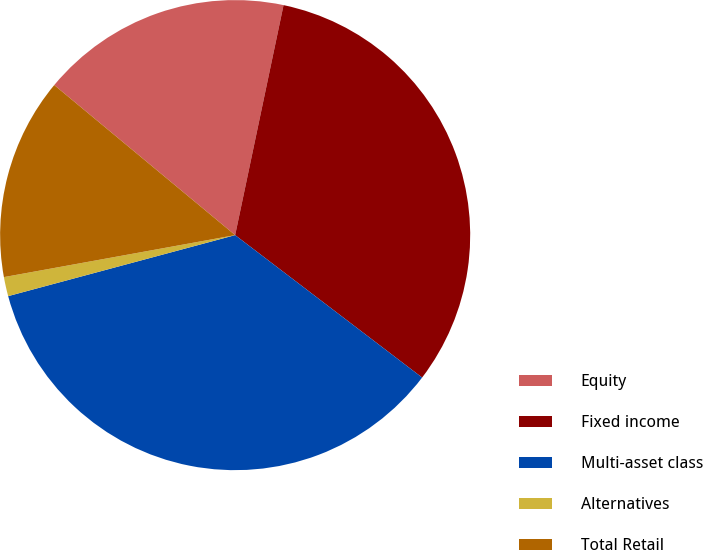<chart> <loc_0><loc_0><loc_500><loc_500><pie_chart><fcel>Equity<fcel>Fixed income<fcel>Multi-asset class<fcel>Alternatives<fcel>Total Retail<nl><fcel>17.28%<fcel>32.06%<fcel>35.46%<fcel>1.32%<fcel>13.88%<nl></chart> 